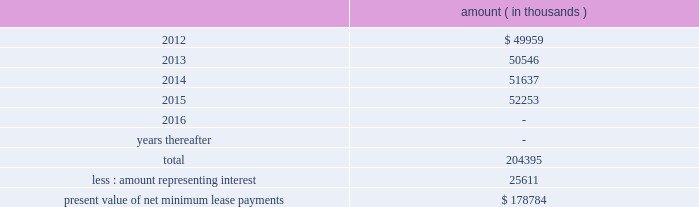Entergy corporation and subsidiaries notes to financial statements ferc audit report , system energy initially recorded as a net regulatory asset the difference between the recovery of the lease payments and the amounts expensed for interest and depreciation and continues to record this difference as a regulatory asset or liability on an ongoing basis , resulting in a zero net balance for the regulatory asset at the end of the lease term .
The amount was a net regulatory asset ( liability ) of ( $ 2.0 ) million and $ 60.6 million as of december 31 , 2011 and 2010 , respectively .
As of december 31 , 2011 , system energy had future minimum lease payments ( reflecting an implicit rate of 5.13% ( 5.13 % ) ) , which are recorded as long-term debt as follows : amount ( in thousands ) .

In how many years will is the company expected to pay off all its future minimum lease payments? 
Computations: (2015 - 2011)
Answer: 4.0. 